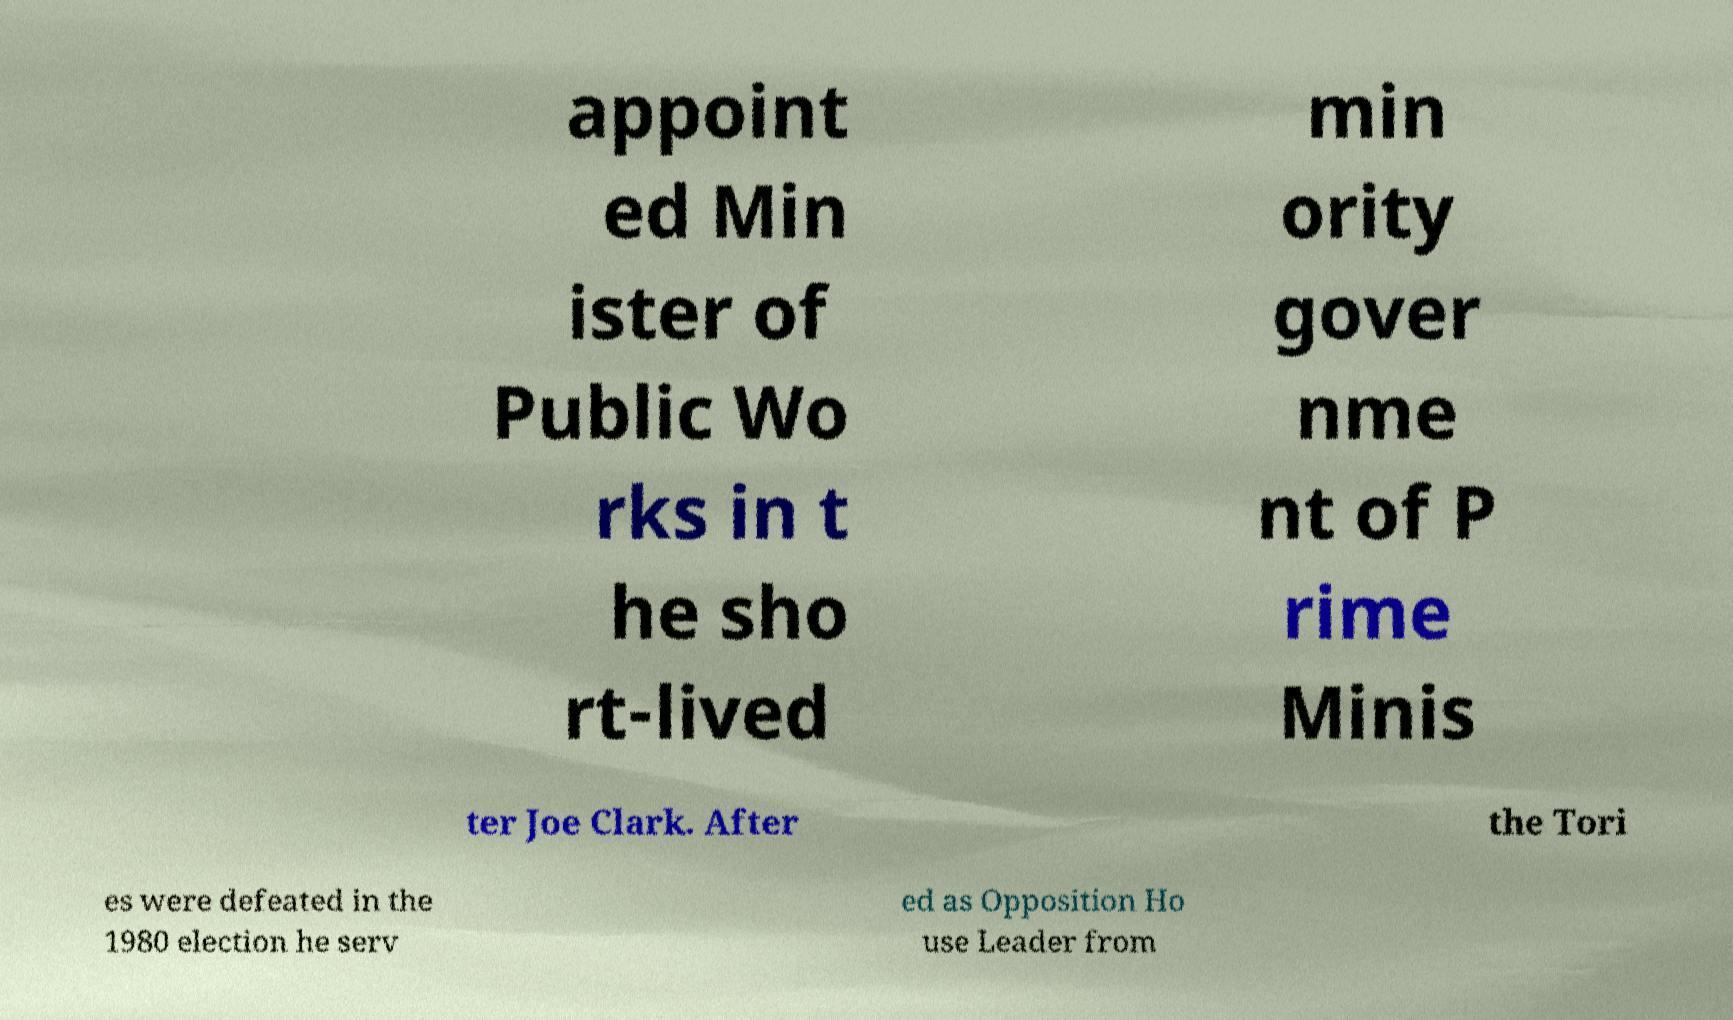I need the written content from this picture converted into text. Can you do that? appoint ed Min ister of Public Wo rks in t he sho rt-lived min ority gover nme nt of P rime Minis ter Joe Clark. After the Tori es were defeated in the 1980 election he serv ed as Opposition Ho use Leader from 